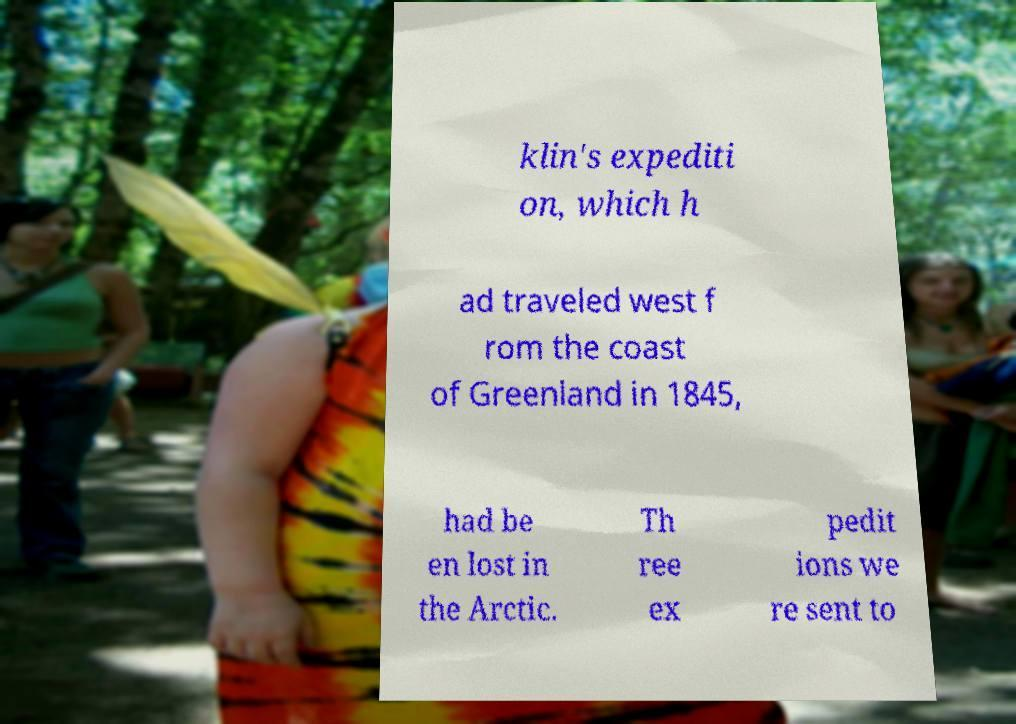Can you read and provide the text displayed in the image?This photo seems to have some interesting text. Can you extract and type it out for me? klin's expediti on, which h ad traveled west f rom the coast of Greenland in 1845, had be en lost in the Arctic. Th ree ex pedit ions we re sent to 